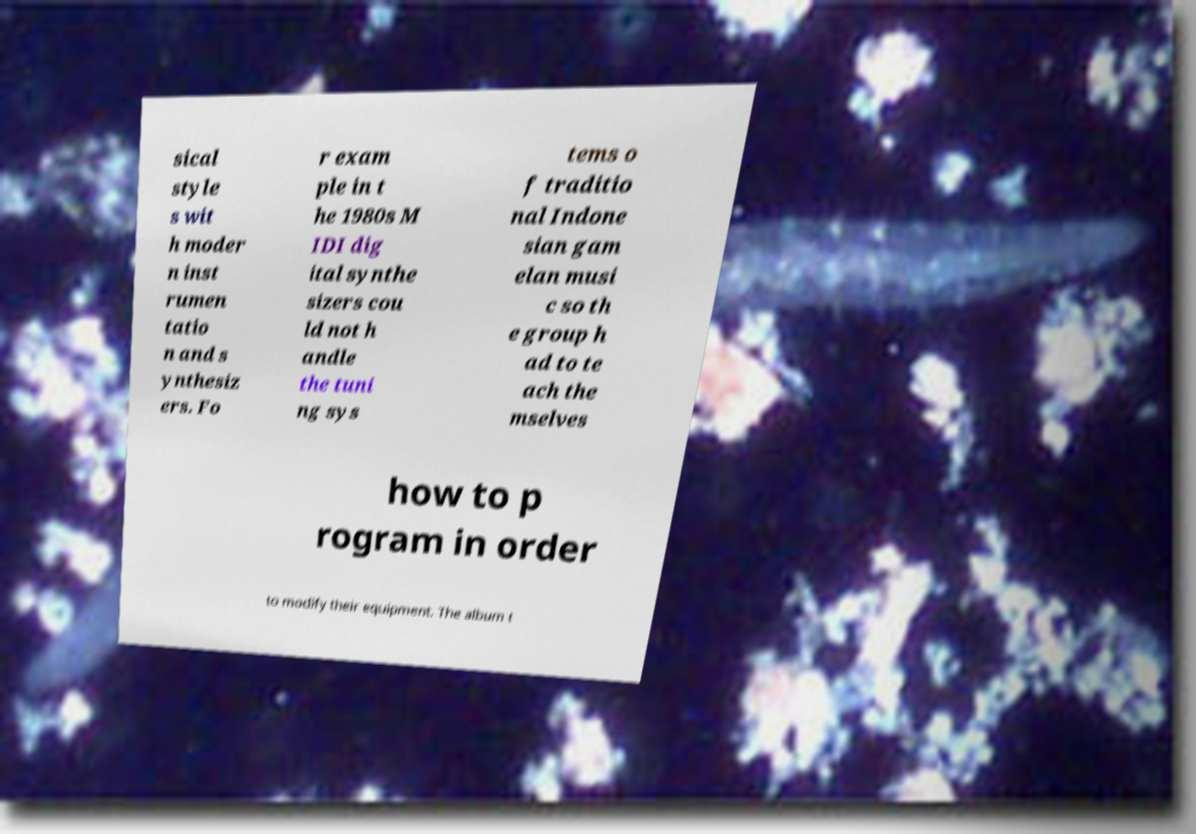Please identify and transcribe the text found in this image. sical style s wit h moder n inst rumen tatio n and s ynthesiz ers. Fo r exam ple in t he 1980s M IDI dig ital synthe sizers cou ld not h andle the tuni ng sys tems o f traditio nal Indone sian gam elan musi c so th e group h ad to te ach the mselves how to p rogram in order to modify their equipment. The album t 